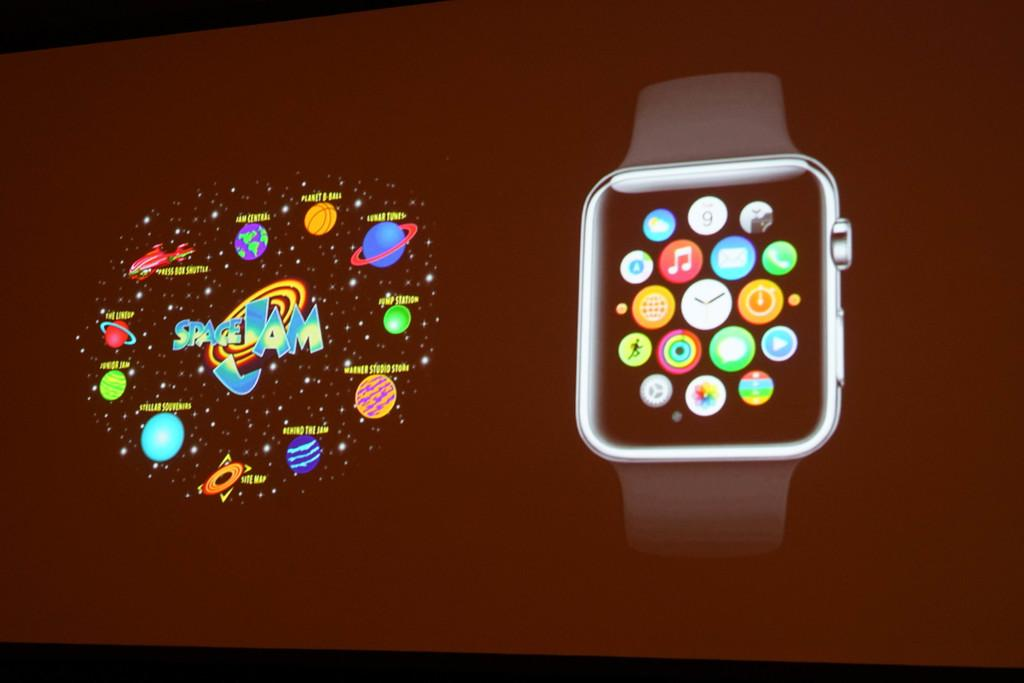Provide a one-sentence caption for the provided image. A screen of the apple watch and a Space Jam layout. 